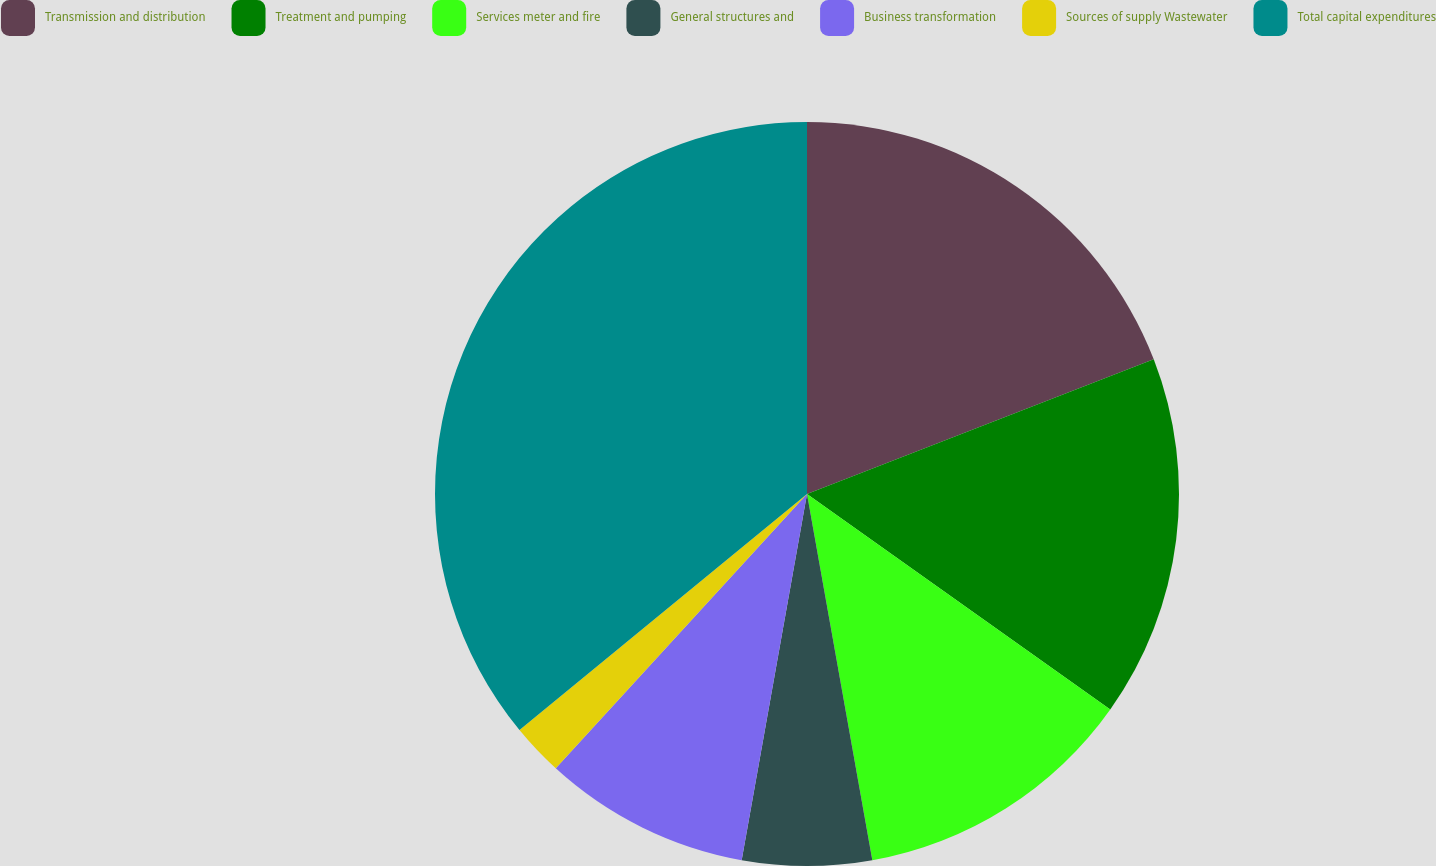Convert chart to OTSL. <chart><loc_0><loc_0><loc_500><loc_500><pie_chart><fcel>Transmission and distribution<fcel>Treatment and pumping<fcel>Services meter and fire<fcel>General structures and<fcel>Business transformation<fcel>Sources of supply Wastewater<fcel>Total capital expenditures<nl><fcel>19.1%<fcel>15.73%<fcel>12.36%<fcel>5.62%<fcel>8.99%<fcel>2.26%<fcel>35.94%<nl></chart> 